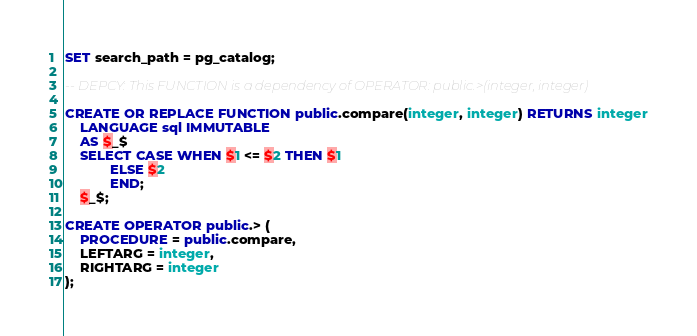<code> <loc_0><loc_0><loc_500><loc_500><_SQL_>SET search_path = pg_catalog;

-- DEPCY: This FUNCTION is a dependency of OPERATOR: public.>(integer, integer)

CREATE OR REPLACE FUNCTION public.compare(integer, integer) RETURNS integer
    LANGUAGE sql IMMUTABLE
    AS $_$
    SELECT CASE WHEN $1 <= $2 THEN $1
            ELSE $2
            END;
    $_$;

CREATE OPERATOR public.> (
	PROCEDURE = public.compare,
	LEFTARG = integer,
	RIGHTARG = integer
);</code> 